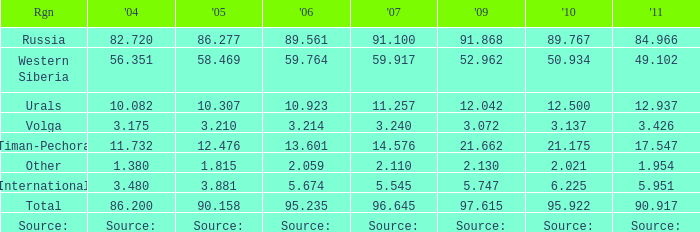What is the 2005 Lukoil oil prodroduction when in 2007 oil production 5.545 million tonnes? 3.881. 